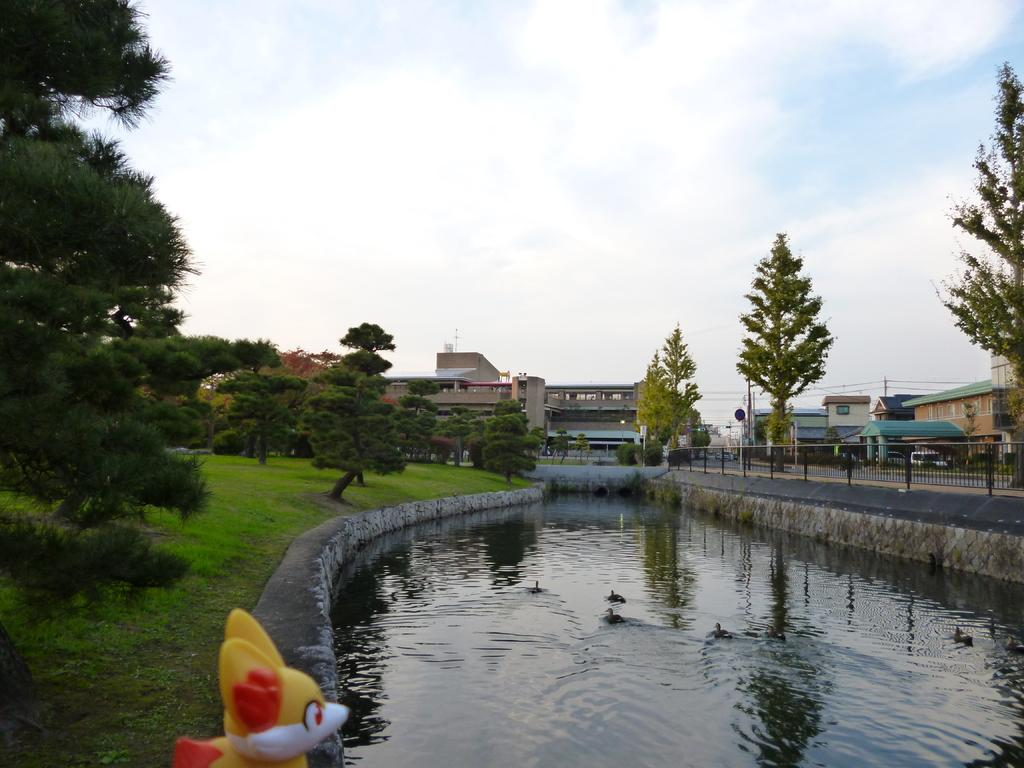What body of water is present in the image? There is a lake in the image. What type of vegetation surrounds the lake? There are trees and plants around the lake. What type of structures can be seen in the image? There are buildings and houses in the image. What type of jewel can be seen in the lake in the image? There is no jewel present in the lake in the image. What type of yarn is being used to create harmony among the trees in the image? There is no yarn or reference to harmony among the trees in the image. 